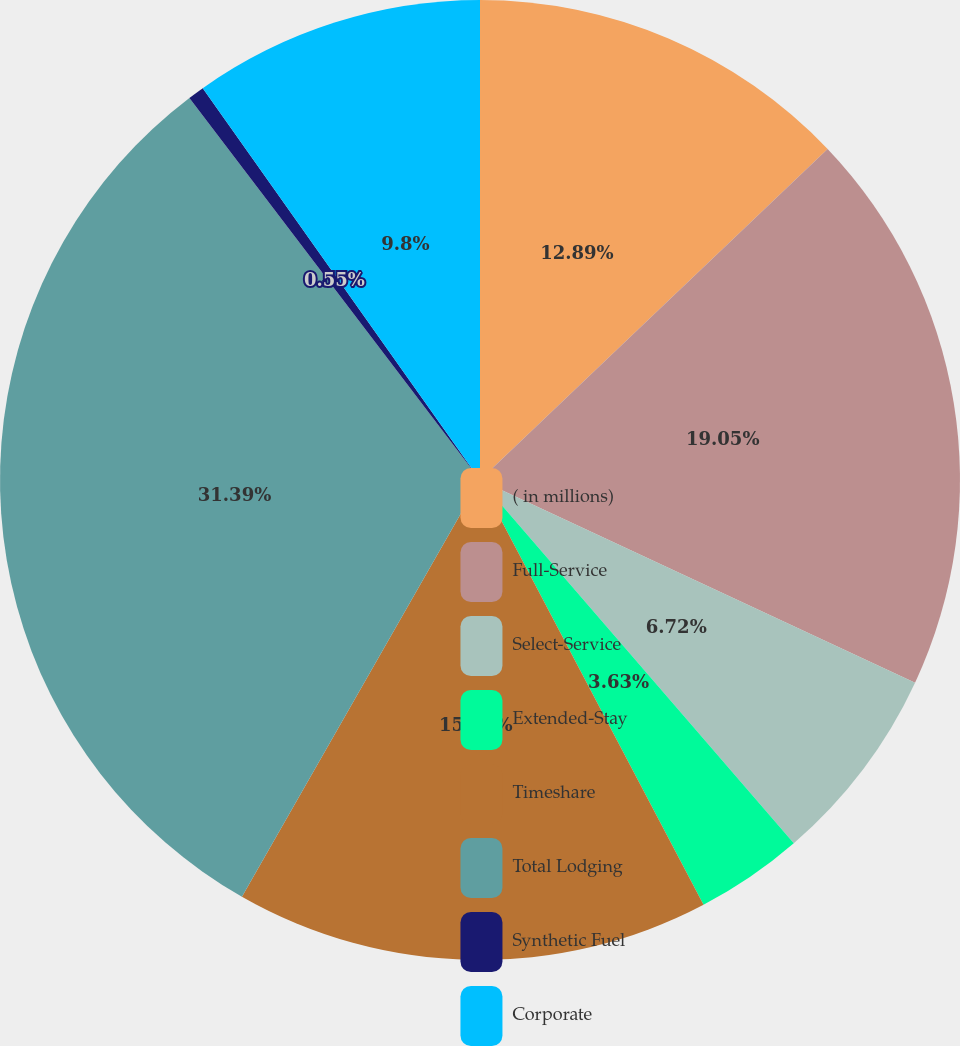Convert chart. <chart><loc_0><loc_0><loc_500><loc_500><pie_chart><fcel>( in millions)<fcel>Full-Service<fcel>Select-Service<fcel>Extended-Stay<fcel>Timeshare<fcel>Total Lodging<fcel>Synthetic Fuel<fcel>Corporate<nl><fcel>12.89%<fcel>19.05%<fcel>6.72%<fcel>3.63%<fcel>15.97%<fcel>31.39%<fcel>0.55%<fcel>9.8%<nl></chart> 